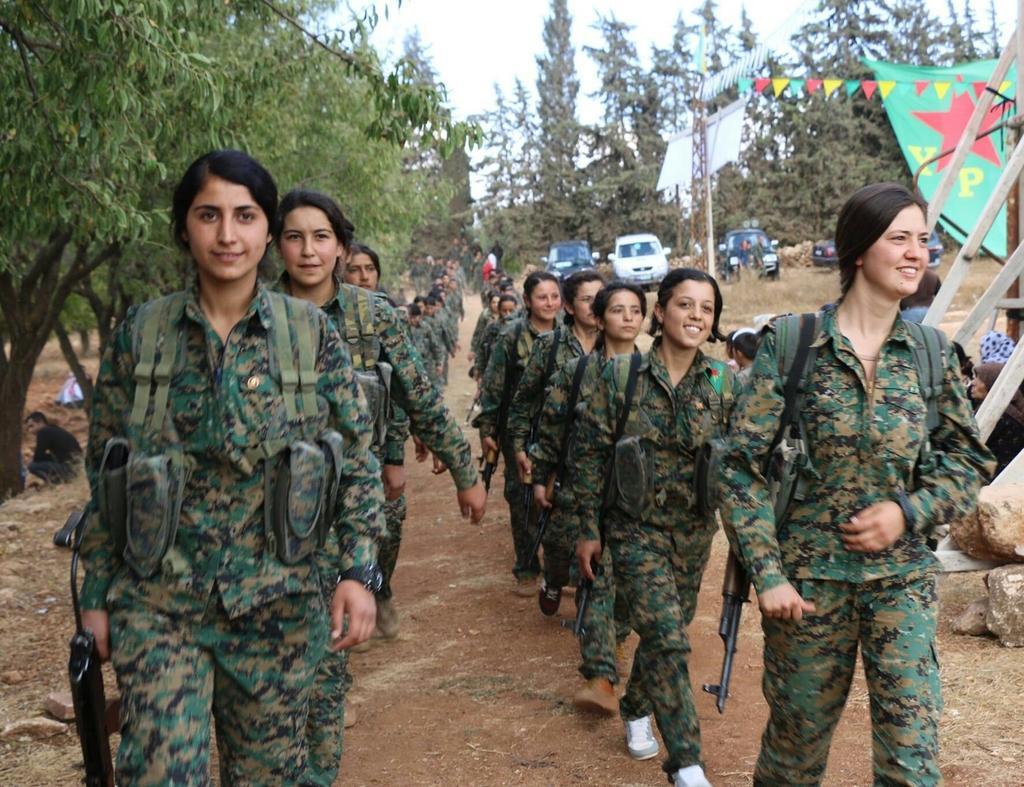Could you give a brief overview of what you see in this image? In the center of the image we can see a group of people are walking and wearing the uniforms, shoes and holding the guns. In the background of the image we can see the trees, vehicles, pole, flags, rods, stones. On the left side of the image we can see a man is sitting on the ground. On the right side of the image we can see some people are sitting. At the bottom of the image we can see the ground and stones. At the top of the image we can see the sky. 